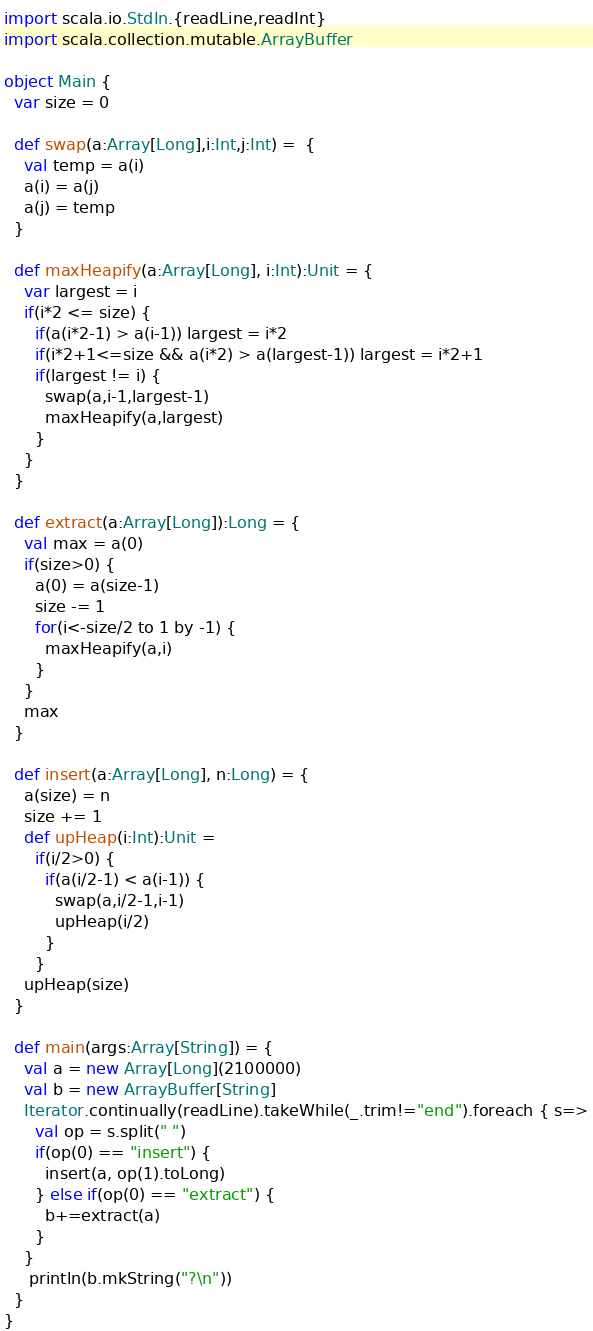<code> <loc_0><loc_0><loc_500><loc_500><_Scala_>import scala.io.StdIn.{readLine,readInt}
import scala.collection.mutable.ArrayBuffer

object Main {
  var size = 0

  def swap(a:Array[Long],i:Int,j:Int) =  {
    val temp = a(i)
    a(i) = a(j)
    a(j) = temp
  }

  def maxHeapify(a:Array[Long], i:Int):Unit = {
    var largest = i
    if(i*2 <= size) {
      if(a(i*2-1) > a(i-1)) largest = i*2
      if(i*2+1<=size && a(i*2) > a(largest-1)) largest = i*2+1
      if(largest != i) {
        swap(a,i-1,largest-1)
        maxHeapify(a,largest)
      }
    }
  }

  def extract(a:Array[Long]):Long = {
    val max = a(0)
    if(size>0) {
      a(0) = a(size-1)
      size -= 1
      for(i<-size/2 to 1 by -1) {
        maxHeapify(a,i)
      }
    }
    max
  }

  def insert(a:Array[Long], n:Long) = {
    a(size) = n
    size += 1
    def upHeap(i:Int):Unit =
      if(i/2>0) {
        if(a(i/2-1) < a(i-1)) {
          swap(a,i/2-1,i-1)
          upHeap(i/2)
        }
      }
    upHeap(size)
  }

  def main(args:Array[String]) = {
    val a = new Array[Long](2100000)
    val b = new ArrayBuffer[String]
    Iterator.continually(readLine).takeWhile(_.trim!="end").foreach { s=>
      val op = s.split(" ")
      if(op(0) == "insert") {
        insert(a, op(1).toLong)
      } else if(op(0) == "extract") {
        b+=extract(a)
      }
    }
     println(b.mkString("?\n"))
  }
}</code> 